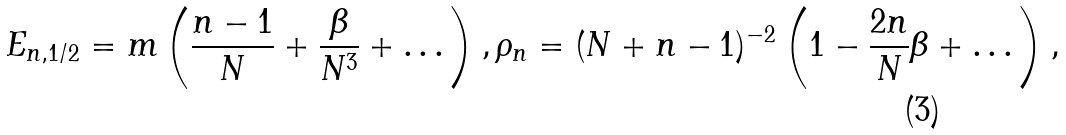<formula> <loc_0><loc_0><loc_500><loc_500>E _ { n , 1 / 2 } = m \left ( \frac { n - 1 } { N } + \frac { \beta } { N ^ { 3 } } + \dots \right ) , \rho _ { n } = ( N + n - 1 ) ^ { - 2 } \left ( 1 - \frac { 2 n } { N } \beta + \dots \right ) ,</formula> 